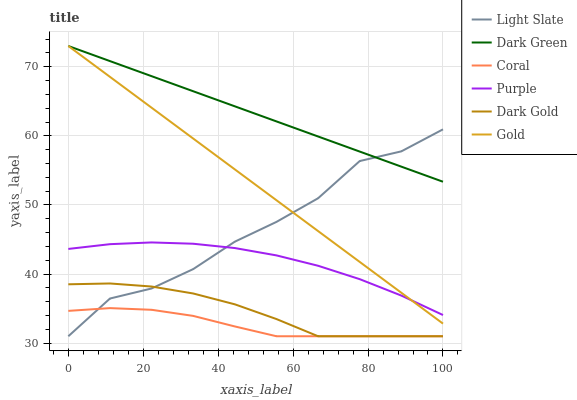Does Coral have the minimum area under the curve?
Answer yes or no. Yes. Does Dark Green have the maximum area under the curve?
Answer yes or no. Yes. Does Dark Gold have the minimum area under the curve?
Answer yes or no. No. Does Dark Gold have the maximum area under the curve?
Answer yes or no. No. Is Dark Green the smoothest?
Answer yes or no. Yes. Is Light Slate the roughest?
Answer yes or no. Yes. Is Dark Gold the smoothest?
Answer yes or no. No. Is Dark Gold the roughest?
Answer yes or no. No. Does Dark Gold have the lowest value?
Answer yes or no. Yes. Does Purple have the lowest value?
Answer yes or no. No. Does Dark Green have the highest value?
Answer yes or no. Yes. Does Dark Gold have the highest value?
Answer yes or no. No. Is Dark Gold less than Gold?
Answer yes or no. Yes. Is Gold greater than Coral?
Answer yes or no. Yes. Does Gold intersect Dark Green?
Answer yes or no. Yes. Is Gold less than Dark Green?
Answer yes or no. No. Is Gold greater than Dark Green?
Answer yes or no. No. Does Dark Gold intersect Gold?
Answer yes or no. No. 